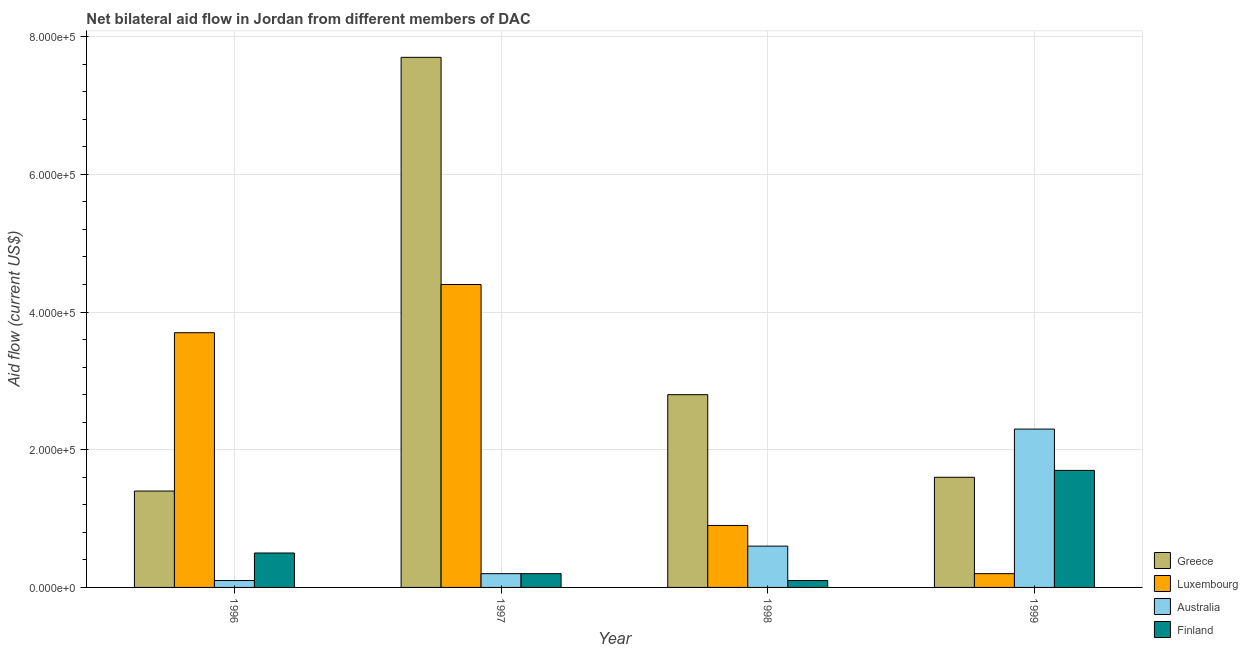Are the number of bars on each tick of the X-axis equal?
Your answer should be compact. Yes. How many bars are there on the 4th tick from the right?
Ensure brevity in your answer.  4. What is the label of the 2nd group of bars from the left?
Your answer should be very brief. 1997. In how many cases, is the number of bars for a given year not equal to the number of legend labels?
Ensure brevity in your answer.  0. What is the amount of aid given by greece in 1996?
Give a very brief answer. 1.40e+05. Across all years, what is the maximum amount of aid given by australia?
Make the answer very short. 2.30e+05. Across all years, what is the minimum amount of aid given by finland?
Offer a very short reply. 10000. In which year was the amount of aid given by luxembourg maximum?
Offer a terse response. 1997. In which year was the amount of aid given by finland minimum?
Your answer should be very brief. 1998. What is the total amount of aid given by greece in the graph?
Provide a short and direct response. 1.35e+06. What is the difference between the amount of aid given by finland in 1996 and that in 1997?
Your answer should be very brief. 3.00e+04. What is the difference between the amount of aid given by finland in 1997 and the amount of aid given by greece in 1996?
Provide a succinct answer. -3.00e+04. Is the difference between the amount of aid given by finland in 1996 and 1998 greater than the difference between the amount of aid given by luxembourg in 1996 and 1998?
Provide a short and direct response. No. What is the difference between the highest and the lowest amount of aid given by luxembourg?
Make the answer very short. 4.20e+05. What does the 2nd bar from the left in 1996 represents?
Ensure brevity in your answer.  Luxembourg. What does the 4th bar from the right in 1998 represents?
Give a very brief answer. Greece. How many years are there in the graph?
Offer a very short reply. 4. What is the difference between two consecutive major ticks on the Y-axis?
Give a very brief answer. 2.00e+05. Are the values on the major ticks of Y-axis written in scientific E-notation?
Offer a very short reply. Yes. Where does the legend appear in the graph?
Give a very brief answer. Bottom right. How are the legend labels stacked?
Your answer should be compact. Vertical. What is the title of the graph?
Your answer should be compact. Net bilateral aid flow in Jordan from different members of DAC. What is the label or title of the Y-axis?
Keep it short and to the point. Aid flow (current US$). What is the Aid flow (current US$) in Greece in 1996?
Your answer should be compact. 1.40e+05. What is the Aid flow (current US$) of Luxembourg in 1996?
Make the answer very short. 3.70e+05. What is the Aid flow (current US$) in Australia in 1996?
Keep it short and to the point. 10000. What is the Aid flow (current US$) in Finland in 1996?
Your answer should be very brief. 5.00e+04. What is the Aid flow (current US$) of Greece in 1997?
Provide a short and direct response. 7.70e+05. What is the Aid flow (current US$) in Luxembourg in 1997?
Your answer should be compact. 4.40e+05. What is the Aid flow (current US$) of Australia in 1997?
Ensure brevity in your answer.  2.00e+04. What is the Aid flow (current US$) in Greece in 1998?
Your response must be concise. 2.80e+05. What is the Aid flow (current US$) of Luxembourg in 1998?
Ensure brevity in your answer.  9.00e+04. What is the Aid flow (current US$) in Finland in 1998?
Your answer should be very brief. 10000. What is the Aid flow (current US$) in Australia in 1999?
Offer a terse response. 2.30e+05. Across all years, what is the maximum Aid flow (current US$) in Greece?
Your answer should be compact. 7.70e+05. Across all years, what is the minimum Aid flow (current US$) in Greece?
Offer a very short reply. 1.40e+05. Across all years, what is the minimum Aid flow (current US$) in Australia?
Your response must be concise. 10000. Across all years, what is the minimum Aid flow (current US$) of Finland?
Your answer should be very brief. 10000. What is the total Aid flow (current US$) in Greece in the graph?
Offer a terse response. 1.35e+06. What is the total Aid flow (current US$) in Luxembourg in the graph?
Your answer should be very brief. 9.20e+05. What is the total Aid flow (current US$) of Finland in the graph?
Give a very brief answer. 2.50e+05. What is the difference between the Aid flow (current US$) in Greece in 1996 and that in 1997?
Your response must be concise. -6.30e+05. What is the difference between the Aid flow (current US$) in Australia in 1996 and that in 1997?
Keep it short and to the point. -10000. What is the difference between the Aid flow (current US$) in Finland in 1996 and that in 1997?
Your answer should be compact. 3.00e+04. What is the difference between the Aid flow (current US$) of Greece in 1996 and that in 1998?
Offer a very short reply. -1.40e+05. What is the difference between the Aid flow (current US$) in Greece in 1996 and that in 1999?
Make the answer very short. -2.00e+04. What is the difference between the Aid flow (current US$) in Finland in 1996 and that in 1999?
Make the answer very short. -1.20e+05. What is the difference between the Aid flow (current US$) of Luxembourg in 1997 and that in 1998?
Your answer should be very brief. 3.50e+05. What is the difference between the Aid flow (current US$) in Australia in 1997 and that in 1998?
Your answer should be compact. -4.00e+04. What is the difference between the Aid flow (current US$) of Greece in 1997 and that in 1999?
Your answer should be compact. 6.10e+05. What is the difference between the Aid flow (current US$) in Luxembourg in 1997 and that in 1999?
Your answer should be very brief. 4.20e+05. What is the difference between the Aid flow (current US$) of Finland in 1997 and that in 1999?
Offer a very short reply. -1.50e+05. What is the difference between the Aid flow (current US$) of Luxembourg in 1998 and that in 1999?
Provide a short and direct response. 7.00e+04. What is the difference between the Aid flow (current US$) of Greece in 1996 and the Aid flow (current US$) of Australia in 1997?
Offer a very short reply. 1.20e+05. What is the difference between the Aid flow (current US$) in Greece in 1996 and the Aid flow (current US$) in Finland in 1997?
Provide a short and direct response. 1.20e+05. What is the difference between the Aid flow (current US$) of Australia in 1996 and the Aid flow (current US$) of Finland in 1997?
Keep it short and to the point. -10000. What is the difference between the Aid flow (current US$) of Luxembourg in 1996 and the Aid flow (current US$) of Australia in 1998?
Offer a terse response. 3.10e+05. What is the difference between the Aid flow (current US$) in Australia in 1996 and the Aid flow (current US$) in Finland in 1998?
Provide a succinct answer. 0. What is the difference between the Aid flow (current US$) in Greece in 1996 and the Aid flow (current US$) in Luxembourg in 1999?
Make the answer very short. 1.20e+05. What is the difference between the Aid flow (current US$) of Greece in 1996 and the Aid flow (current US$) of Australia in 1999?
Make the answer very short. -9.00e+04. What is the difference between the Aid flow (current US$) of Luxembourg in 1996 and the Aid flow (current US$) of Australia in 1999?
Your answer should be very brief. 1.40e+05. What is the difference between the Aid flow (current US$) of Luxembourg in 1996 and the Aid flow (current US$) of Finland in 1999?
Ensure brevity in your answer.  2.00e+05. What is the difference between the Aid flow (current US$) in Greece in 1997 and the Aid flow (current US$) in Luxembourg in 1998?
Give a very brief answer. 6.80e+05. What is the difference between the Aid flow (current US$) of Greece in 1997 and the Aid flow (current US$) of Australia in 1998?
Keep it short and to the point. 7.10e+05. What is the difference between the Aid flow (current US$) of Greece in 1997 and the Aid flow (current US$) of Finland in 1998?
Offer a very short reply. 7.60e+05. What is the difference between the Aid flow (current US$) in Luxembourg in 1997 and the Aid flow (current US$) in Australia in 1998?
Your answer should be compact. 3.80e+05. What is the difference between the Aid flow (current US$) in Greece in 1997 and the Aid flow (current US$) in Luxembourg in 1999?
Make the answer very short. 7.50e+05. What is the difference between the Aid flow (current US$) in Greece in 1997 and the Aid flow (current US$) in Australia in 1999?
Make the answer very short. 5.40e+05. What is the difference between the Aid flow (current US$) of Greece in 1997 and the Aid flow (current US$) of Finland in 1999?
Offer a very short reply. 6.00e+05. What is the difference between the Aid flow (current US$) in Luxembourg in 1997 and the Aid flow (current US$) in Finland in 1999?
Offer a terse response. 2.70e+05. What is the difference between the Aid flow (current US$) in Greece in 1998 and the Aid flow (current US$) in Australia in 1999?
Offer a terse response. 5.00e+04. What is the difference between the Aid flow (current US$) of Greece in 1998 and the Aid flow (current US$) of Finland in 1999?
Provide a succinct answer. 1.10e+05. What is the difference between the Aid flow (current US$) in Luxembourg in 1998 and the Aid flow (current US$) in Australia in 1999?
Your answer should be very brief. -1.40e+05. What is the difference between the Aid flow (current US$) of Luxembourg in 1998 and the Aid flow (current US$) of Finland in 1999?
Offer a terse response. -8.00e+04. What is the difference between the Aid flow (current US$) of Australia in 1998 and the Aid flow (current US$) of Finland in 1999?
Offer a terse response. -1.10e+05. What is the average Aid flow (current US$) in Greece per year?
Ensure brevity in your answer.  3.38e+05. What is the average Aid flow (current US$) in Australia per year?
Make the answer very short. 8.00e+04. What is the average Aid flow (current US$) in Finland per year?
Provide a short and direct response. 6.25e+04. In the year 1996, what is the difference between the Aid flow (current US$) of Greece and Aid flow (current US$) of Luxembourg?
Make the answer very short. -2.30e+05. In the year 1996, what is the difference between the Aid flow (current US$) in Greece and Aid flow (current US$) in Finland?
Provide a short and direct response. 9.00e+04. In the year 1996, what is the difference between the Aid flow (current US$) of Australia and Aid flow (current US$) of Finland?
Make the answer very short. -4.00e+04. In the year 1997, what is the difference between the Aid flow (current US$) of Greece and Aid flow (current US$) of Australia?
Give a very brief answer. 7.50e+05. In the year 1997, what is the difference between the Aid flow (current US$) of Greece and Aid flow (current US$) of Finland?
Your answer should be very brief. 7.50e+05. In the year 1997, what is the difference between the Aid flow (current US$) in Australia and Aid flow (current US$) in Finland?
Your response must be concise. 0. In the year 1998, what is the difference between the Aid flow (current US$) in Greece and Aid flow (current US$) in Luxembourg?
Your response must be concise. 1.90e+05. In the year 1998, what is the difference between the Aid flow (current US$) of Greece and Aid flow (current US$) of Australia?
Make the answer very short. 2.20e+05. In the year 1998, what is the difference between the Aid flow (current US$) of Luxembourg and Aid flow (current US$) of Australia?
Make the answer very short. 3.00e+04. In the year 1998, what is the difference between the Aid flow (current US$) of Luxembourg and Aid flow (current US$) of Finland?
Provide a short and direct response. 8.00e+04. In the year 1999, what is the difference between the Aid flow (current US$) in Greece and Aid flow (current US$) in Luxembourg?
Offer a very short reply. 1.40e+05. In the year 1999, what is the difference between the Aid flow (current US$) of Luxembourg and Aid flow (current US$) of Finland?
Your answer should be compact. -1.50e+05. In the year 1999, what is the difference between the Aid flow (current US$) in Australia and Aid flow (current US$) in Finland?
Give a very brief answer. 6.00e+04. What is the ratio of the Aid flow (current US$) in Greece in 1996 to that in 1997?
Provide a succinct answer. 0.18. What is the ratio of the Aid flow (current US$) in Luxembourg in 1996 to that in 1997?
Make the answer very short. 0.84. What is the ratio of the Aid flow (current US$) of Australia in 1996 to that in 1997?
Your answer should be compact. 0.5. What is the ratio of the Aid flow (current US$) in Luxembourg in 1996 to that in 1998?
Provide a succinct answer. 4.11. What is the ratio of the Aid flow (current US$) of Finland in 1996 to that in 1998?
Your answer should be compact. 5. What is the ratio of the Aid flow (current US$) of Greece in 1996 to that in 1999?
Offer a very short reply. 0.88. What is the ratio of the Aid flow (current US$) of Luxembourg in 1996 to that in 1999?
Your answer should be very brief. 18.5. What is the ratio of the Aid flow (current US$) in Australia in 1996 to that in 1999?
Provide a short and direct response. 0.04. What is the ratio of the Aid flow (current US$) in Finland in 1996 to that in 1999?
Provide a short and direct response. 0.29. What is the ratio of the Aid flow (current US$) of Greece in 1997 to that in 1998?
Ensure brevity in your answer.  2.75. What is the ratio of the Aid flow (current US$) in Luxembourg in 1997 to that in 1998?
Ensure brevity in your answer.  4.89. What is the ratio of the Aid flow (current US$) in Australia in 1997 to that in 1998?
Your answer should be very brief. 0.33. What is the ratio of the Aid flow (current US$) of Finland in 1997 to that in 1998?
Make the answer very short. 2. What is the ratio of the Aid flow (current US$) of Greece in 1997 to that in 1999?
Provide a short and direct response. 4.81. What is the ratio of the Aid flow (current US$) in Luxembourg in 1997 to that in 1999?
Your answer should be compact. 22. What is the ratio of the Aid flow (current US$) of Australia in 1997 to that in 1999?
Offer a very short reply. 0.09. What is the ratio of the Aid flow (current US$) in Finland in 1997 to that in 1999?
Ensure brevity in your answer.  0.12. What is the ratio of the Aid flow (current US$) in Australia in 1998 to that in 1999?
Your response must be concise. 0.26. What is the ratio of the Aid flow (current US$) in Finland in 1998 to that in 1999?
Keep it short and to the point. 0.06. What is the difference between the highest and the second highest Aid flow (current US$) in Luxembourg?
Your answer should be very brief. 7.00e+04. What is the difference between the highest and the second highest Aid flow (current US$) of Australia?
Offer a very short reply. 1.70e+05. What is the difference between the highest and the lowest Aid flow (current US$) in Greece?
Your response must be concise. 6.30e+05. What is the difference between the highest and the lowest Aid flow (current US$) of Australia?
Your answer should be compact. 2.20e+05. What is the difference between the highest and the lowest Aid flow (current US$) of Finland?
Your answer should be very brief. 1.60e+05. 